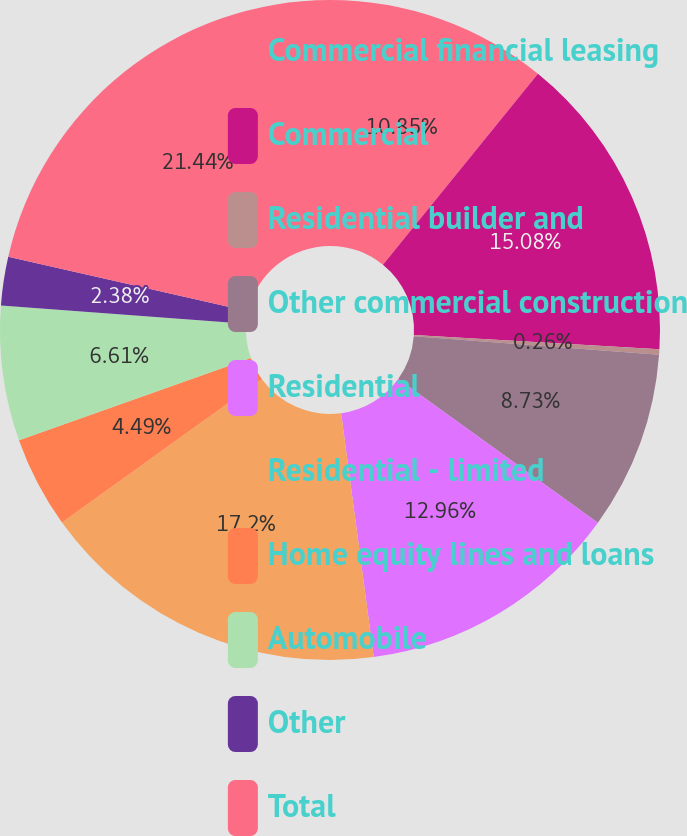Convert chart to OTSL. <chart><loc_0><loc_0><loc_500><loc_500><pie_chart><fcel>Commercial financial leasing<fcel>Commercial<fcel>Residential builder and<fcel>Other commercial construction<fcel>Residential<fcel>Residential - limited<fcel>Home equity lines and loans<fcel>Automobile<fcel>Other<fcel>Total<nl><fcel>10.85%<fcel>15.08%<fcel>0.26%<fcel>8.73%<fcel>12.96%<fcel>17.2%<fcel>4.49%<fcel>6.61%<fcel>2.38%<fcel>21.43%<nl></chart> 